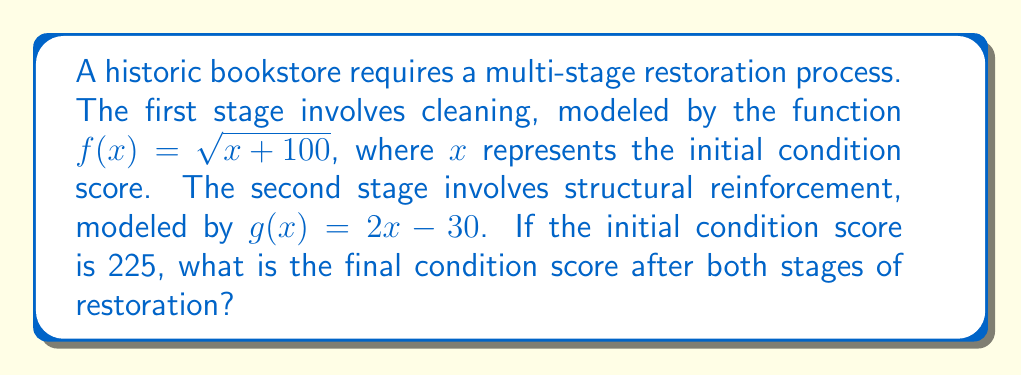Solve this math problem. To solve this problem, we need to compute the composite function $(g \circ f)(x)$ and then evaluate it at $x = 225$. Let's break it down step-by-step:

1) First, we need to find $(g \circ f)(x)$:
   $$(g \circ f)(x) = g(f(x)) = g(\sqrt{x + 100})$$

2) Now, let's substitute $f(x)$ into $g(x)$:
   $$(g \circ f)(x) = 2(\sqrt{x + 100}) - 30$$

3) We now have our composite function. To find the final condition score, we need to evaluate this at $x = 225$:
   $$(g \circ f)(225) = 2(\sqrt{225 + 100}) - 30$$

4) Let's solve this step-by-step:
   $$\begin{align}
   (g \circ f)(225) &= 2(\sqrt{325}) - 30 \\
   &= 2(18.0277...) - 30 \\
   &= 36.0555... - 30 \\
   &= 6.0555...
   \end{align}$$

5) Rounding to two decimal places for a practical score:
   $$(g \circ f)(225) \approx 6.06$$
Answer: The final condition score after both stages of restoration is approximately 6.06. 